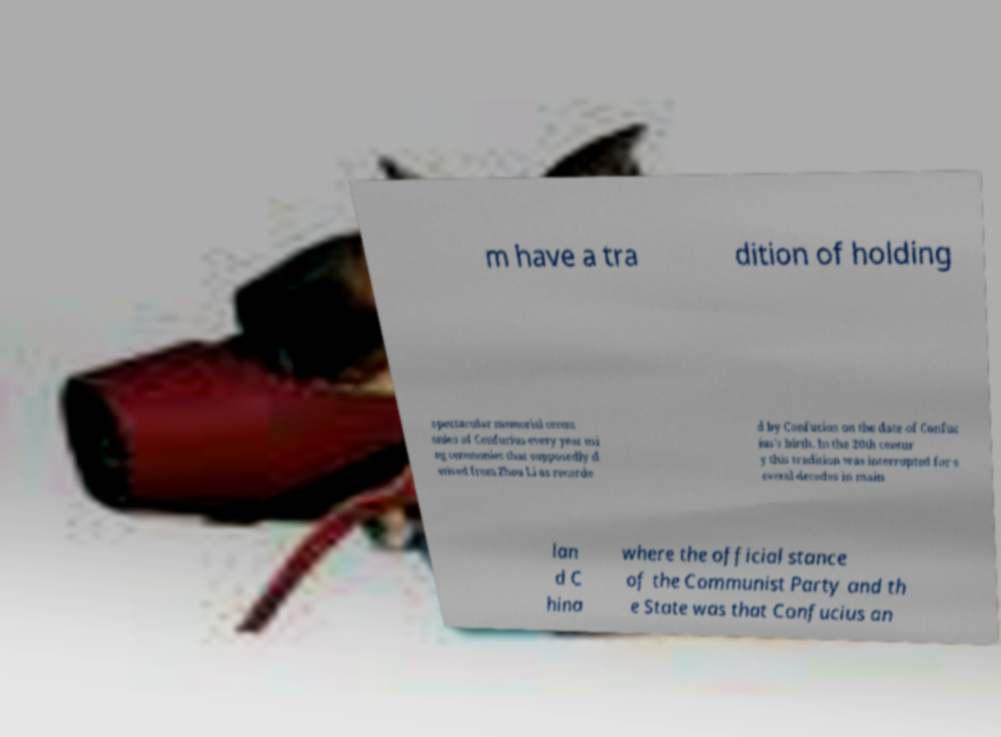Could you extract and type out the text from this image? m have a tra dition of holding spectacular memorial cerem onies of Confucius every year usi ng ceremonies that supposedly d erived from Zhou Li as recorde d by Confucius on the date of Confuc ius's birth. In the 20th centur y this tradition was interrupted for s everal decades in main lan d C hina where the official stance of the Communist Party and th e State was that Confucius an 